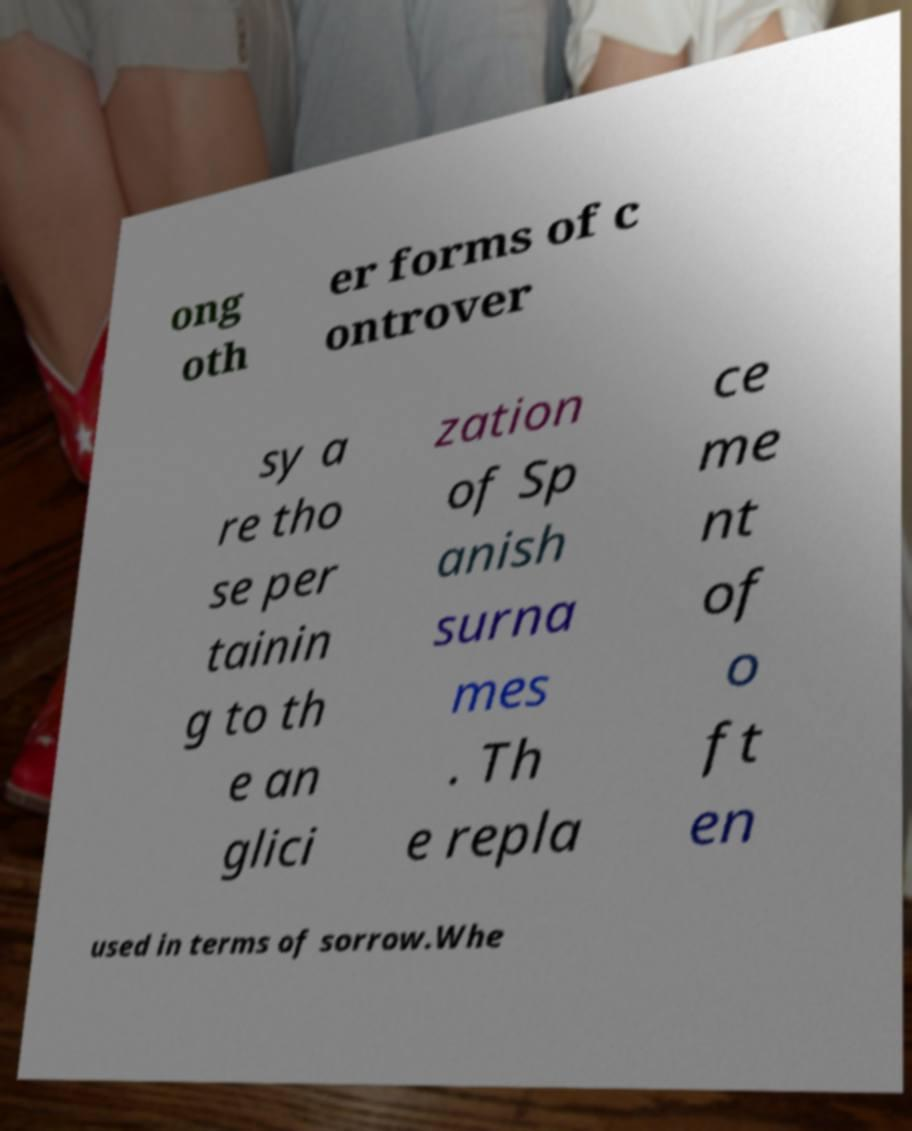I need the written content from this picture converted into text. Can you do that? ong oth er forms of c ontrover sy a re tho se per tainin g to th e an glici zation of Sp anish surna mes . Th e repla ce me nt of o ft en used in terms of sorrow.Whe 